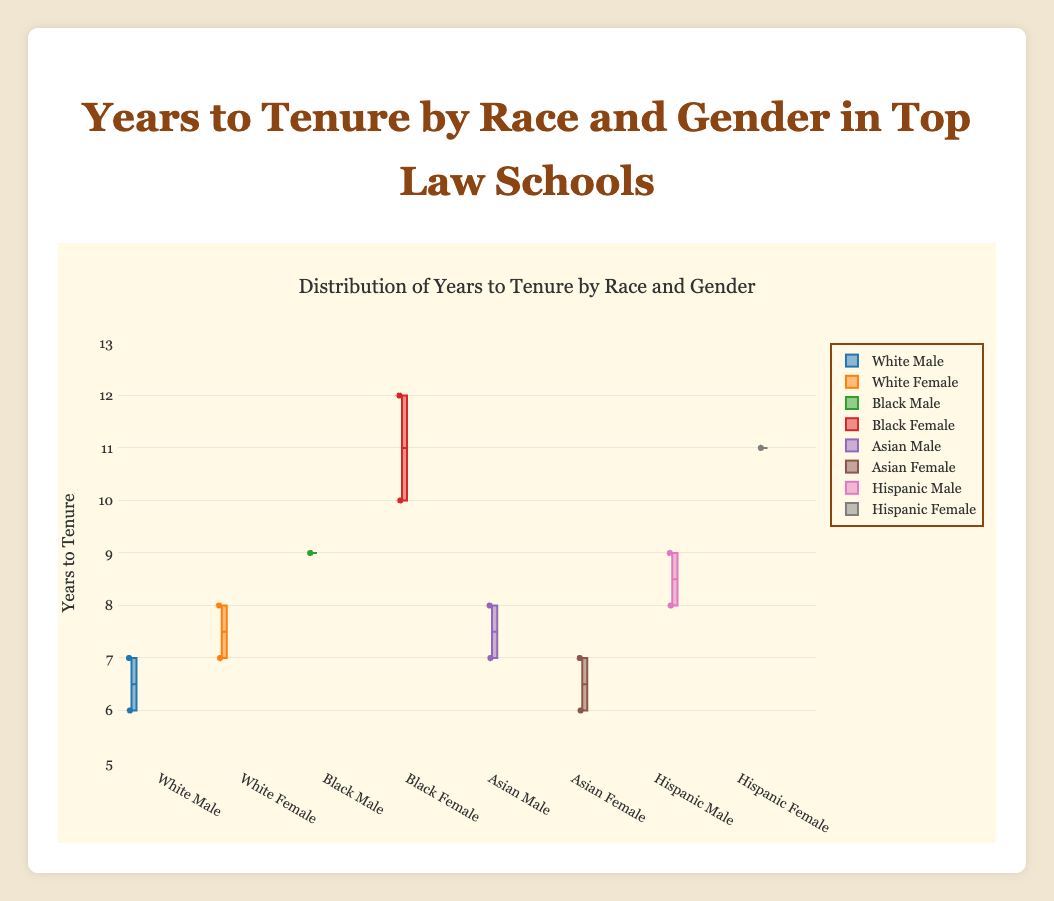What is the title of the figure? The title of the figure is usually located at the top and is meant to give an overview of what the data represents.
Answer: Distribution of Years to Tenure by Race and Gender in Top Law Schools What is the range of the y-axis in the figure? The range of the y-axis is provided in the layout settings and specifies the extent of the data displayed vertically on the plot. In the plot, it ranges from 5 to 13.
Answer: 5 to 13 Which group has the median of years to tenure closest to 8 years? The median in a box plot is represented by the line inside the box. Looking for the box whose median is closest to the horizontal line at 8, which is most visible.
Answer: White Female How many data points are there for the group "Black Female"? In the plot, each box represents all data points under each category, and the points are shown as dots. Count the dots inside the "Black Female" boxplot category.
Answer: 3 Which single data point represents the highest years to tenure in the dataset? Examine the box plots and identify the highest whisker or outlier point. The figure shows the highest single data point is observed in the "Black Female" category at 12 years.
Answer: 12 (Black Female) Are there any gender-based noticeable differences for tenured "White" professors? Compare the medians and ranges of years to tenure in the box plots of "White Male" and "White Female". Observe differences in their distributions.
Answer: Yes, "White Male" generally have lower years to tenure compared to "White Female" Among the groups, which shows the lowest minimum years to tenure? Identify the box plot with the lowest bottom whisker (whisker line reaching downwards from the box). Check each category for the minimum value.
Answer: White Male (6 years) What is the interquartile range (IQR) for "Asian Female"? The IQR in a box plot is the difference between the upper quartile (top edge of the box) and the lower quartile (bottom edge of the box). Locate these edges and calculate the difference.
Answer: IQR is 7 - 6 = 1 Which group has the most outlier points, if any? Outliers in a box plot are displayed as individual points above or below the whiskers. Examine which group has these outlier points distinctly visible.
Answer: Black Female How does the variability in years to tenure compare between "Hispanic Female" and "Asian Female"? Variability can be assessed by looking at the size of the boxes and the length of the whiskers in the box plots for each group. Compare these visual aspects for both categories.
Answer: "Hispanic Female" shows greater variability than "Asian Female" 